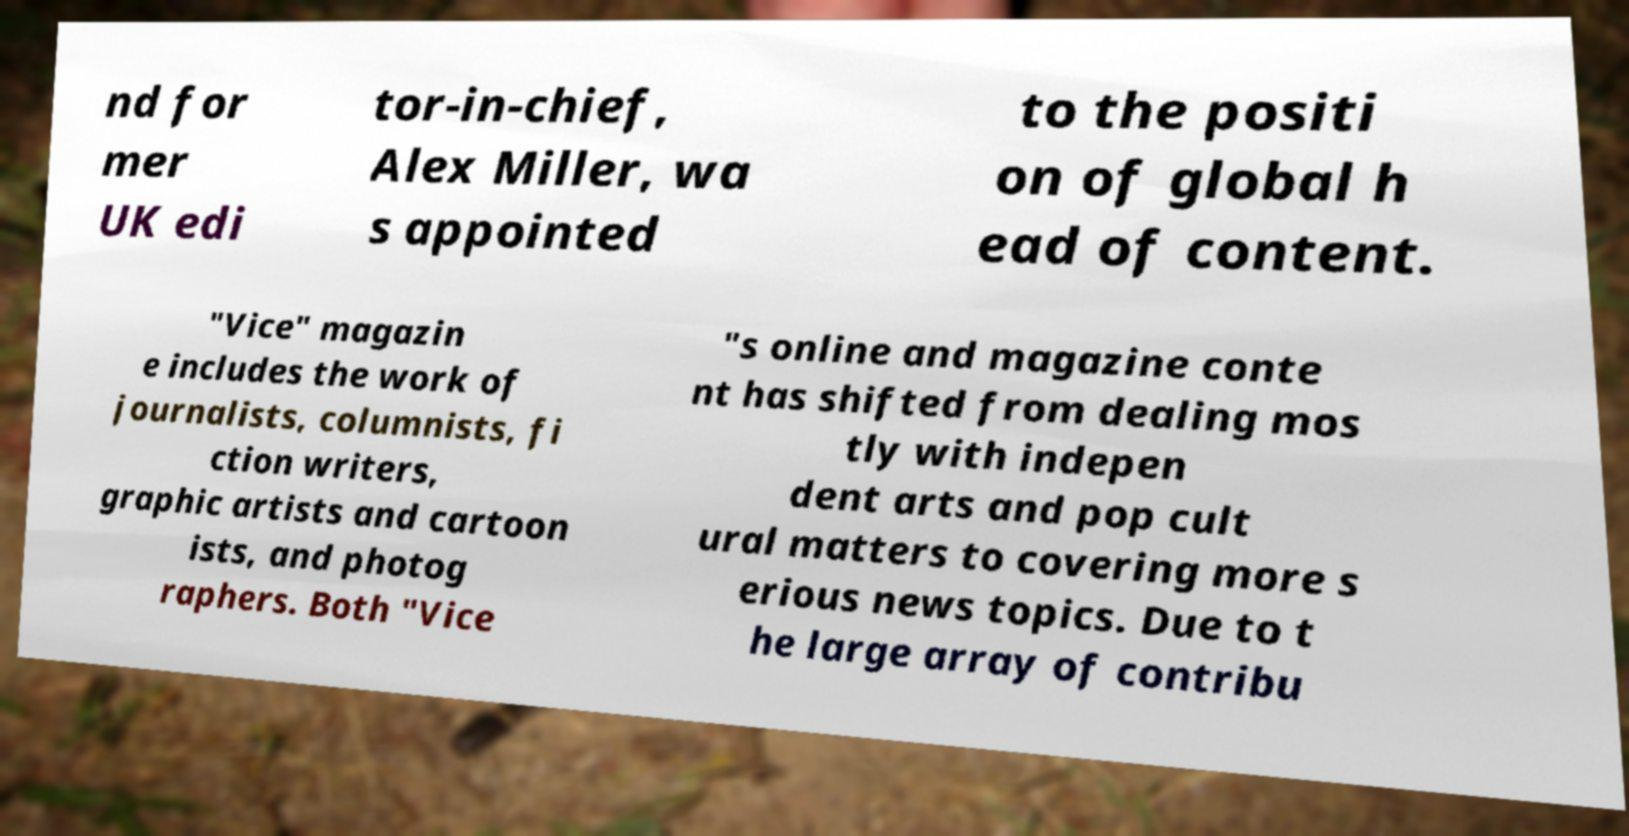What messages or text are displayed in this image? I need them in a readable, typed format. nd for mer UK edi tor-in-chief, Alex Miller, wa s appointed to the positi on of global h ead of content. "Vice" magazin e includes the work of journalists, columnists, fi ction writers, graphic artists and cartoon ists, and photog raphers. Both "Vice "s online and magazine conte nt has shifted from dealing mos tly with indepen dent arts and pop cult ural matters to covering more s erious news topics. Due to t he large array of contribu 